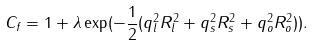<formula> <loc_0><loc_0><loc_500><loc_500>C _ { f } = 1 + \lambda \exp ( - { \frac { 1 } { 2 } } ( q _ { l } ^ { 2 } R _ { l } ^ { 2 } + q _ { s } ^ { 2 } R _ { s } ^ { 2 } + q _ { o } ^ { 2 } R _ { o } ^ { 2 } ) ) .</formula> 